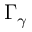Convert formula to latex. <formula><loc_0><loc_0><loc_500><loc_500>\Gamma _ { \gamma }</formula> 